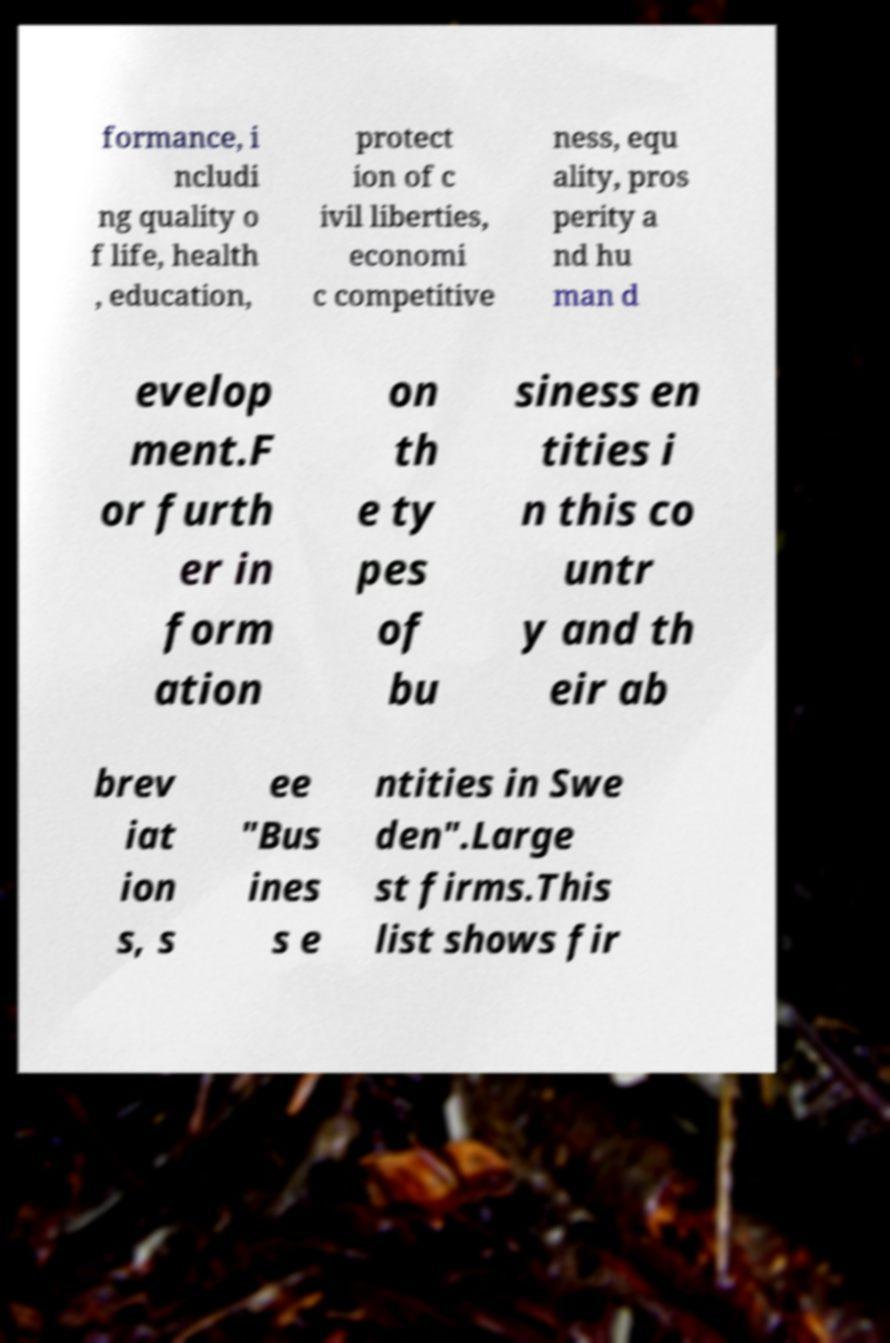Could you assist in decoding the text presented in this image and type it out clearly? formance, i ncludi ng quality o f life, health , education, protect ion of c ivil liberties, economi c competitive ness, equ ality, pros perity a nd hu man d evelop ment.F or furth er in form ation on th e ty pes of bu siness en tities i n this co untr y and th eir ab brev iat ion s, s ee "Bus ines s e ntities in Swe den".Large st firms.This list shows fir 